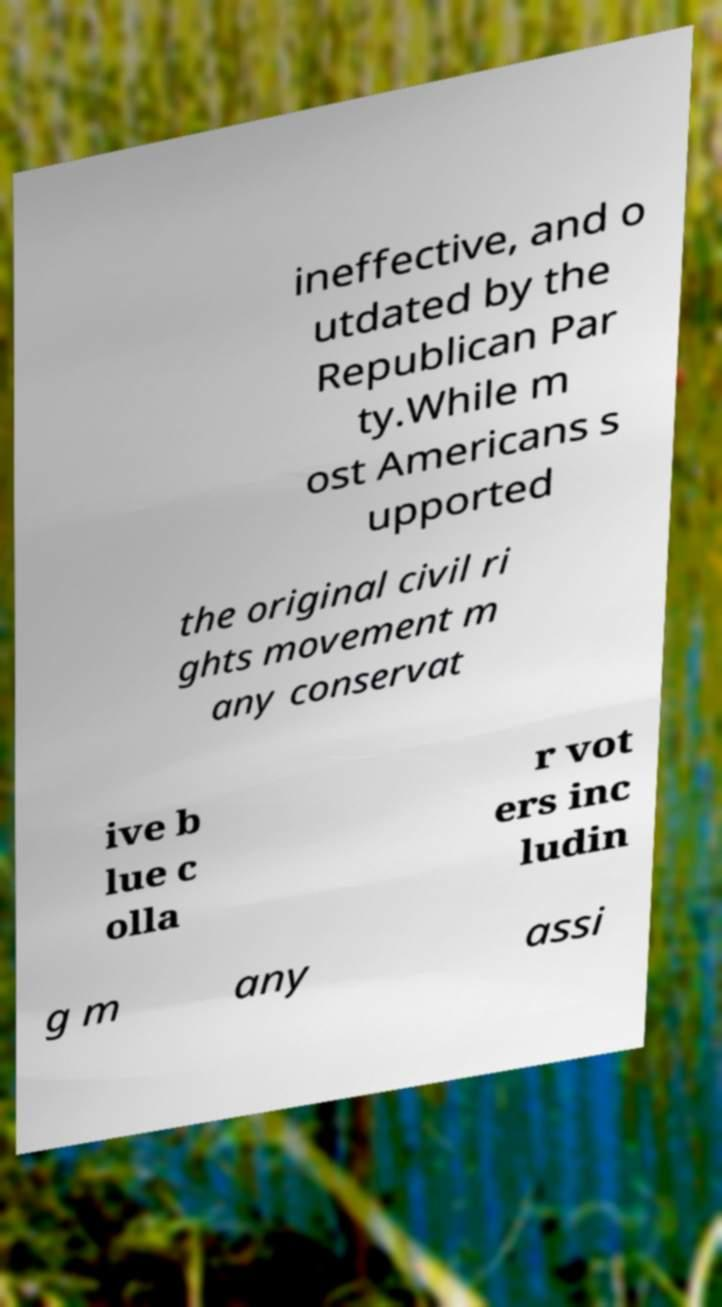I need the written content from this picture converted into text. Can you do that? ineffective, and o utdated by the Republican Par ty.While m ost Americans s upported the original civil ri ghts movement m any conservat ive b lue c olla r vot ers inc ludin g m any assi 